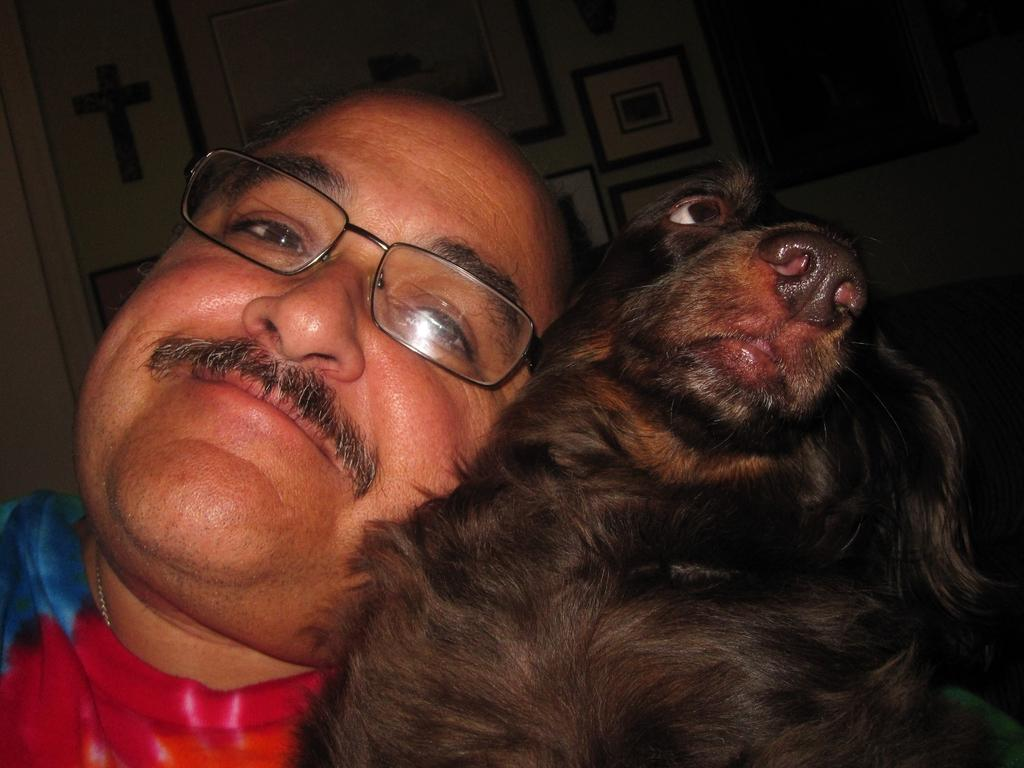What can be seen in the image related to a person? There is a person in the image, and they have a mustache and are wearing glasses. What type of animal is present in the image? There is a black color dog in the image. Where is the dog located in relation to the person? The dog is beside the person. What design element can be observed in the image? There is a beautiful design on the ceiling in the image. What type of circle can be seen on the wall in the image? There is no circle present on the wall in the image. What kind of lumber is being used to construct the furniture in the image? There is no furniture visible in the image, so it is not possible to determine the type of lumber used. 